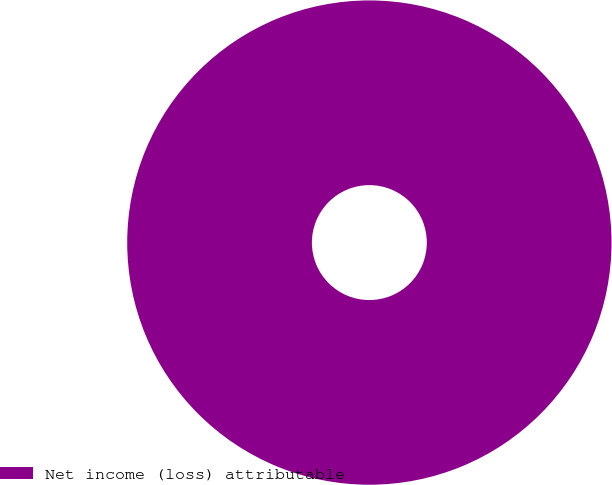Convert chart. <chart><loc_0><loc_0><loc_500><loc_500><pie_chart><fcel>Net income (loss) attributable<nl><fcel>100.0%<nl></chart> 